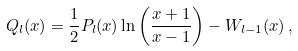<formula> <loc_0><loc_0><loc_500><loc_500>Q _ { l } ( x ) = \frac { 1 } { 2 } P _ { l } ( x ) \ln \left ( \frac { x + 1 } { x - 1 } \right ) - W _ { l - 1 } ( x ) \, ,</formula> 